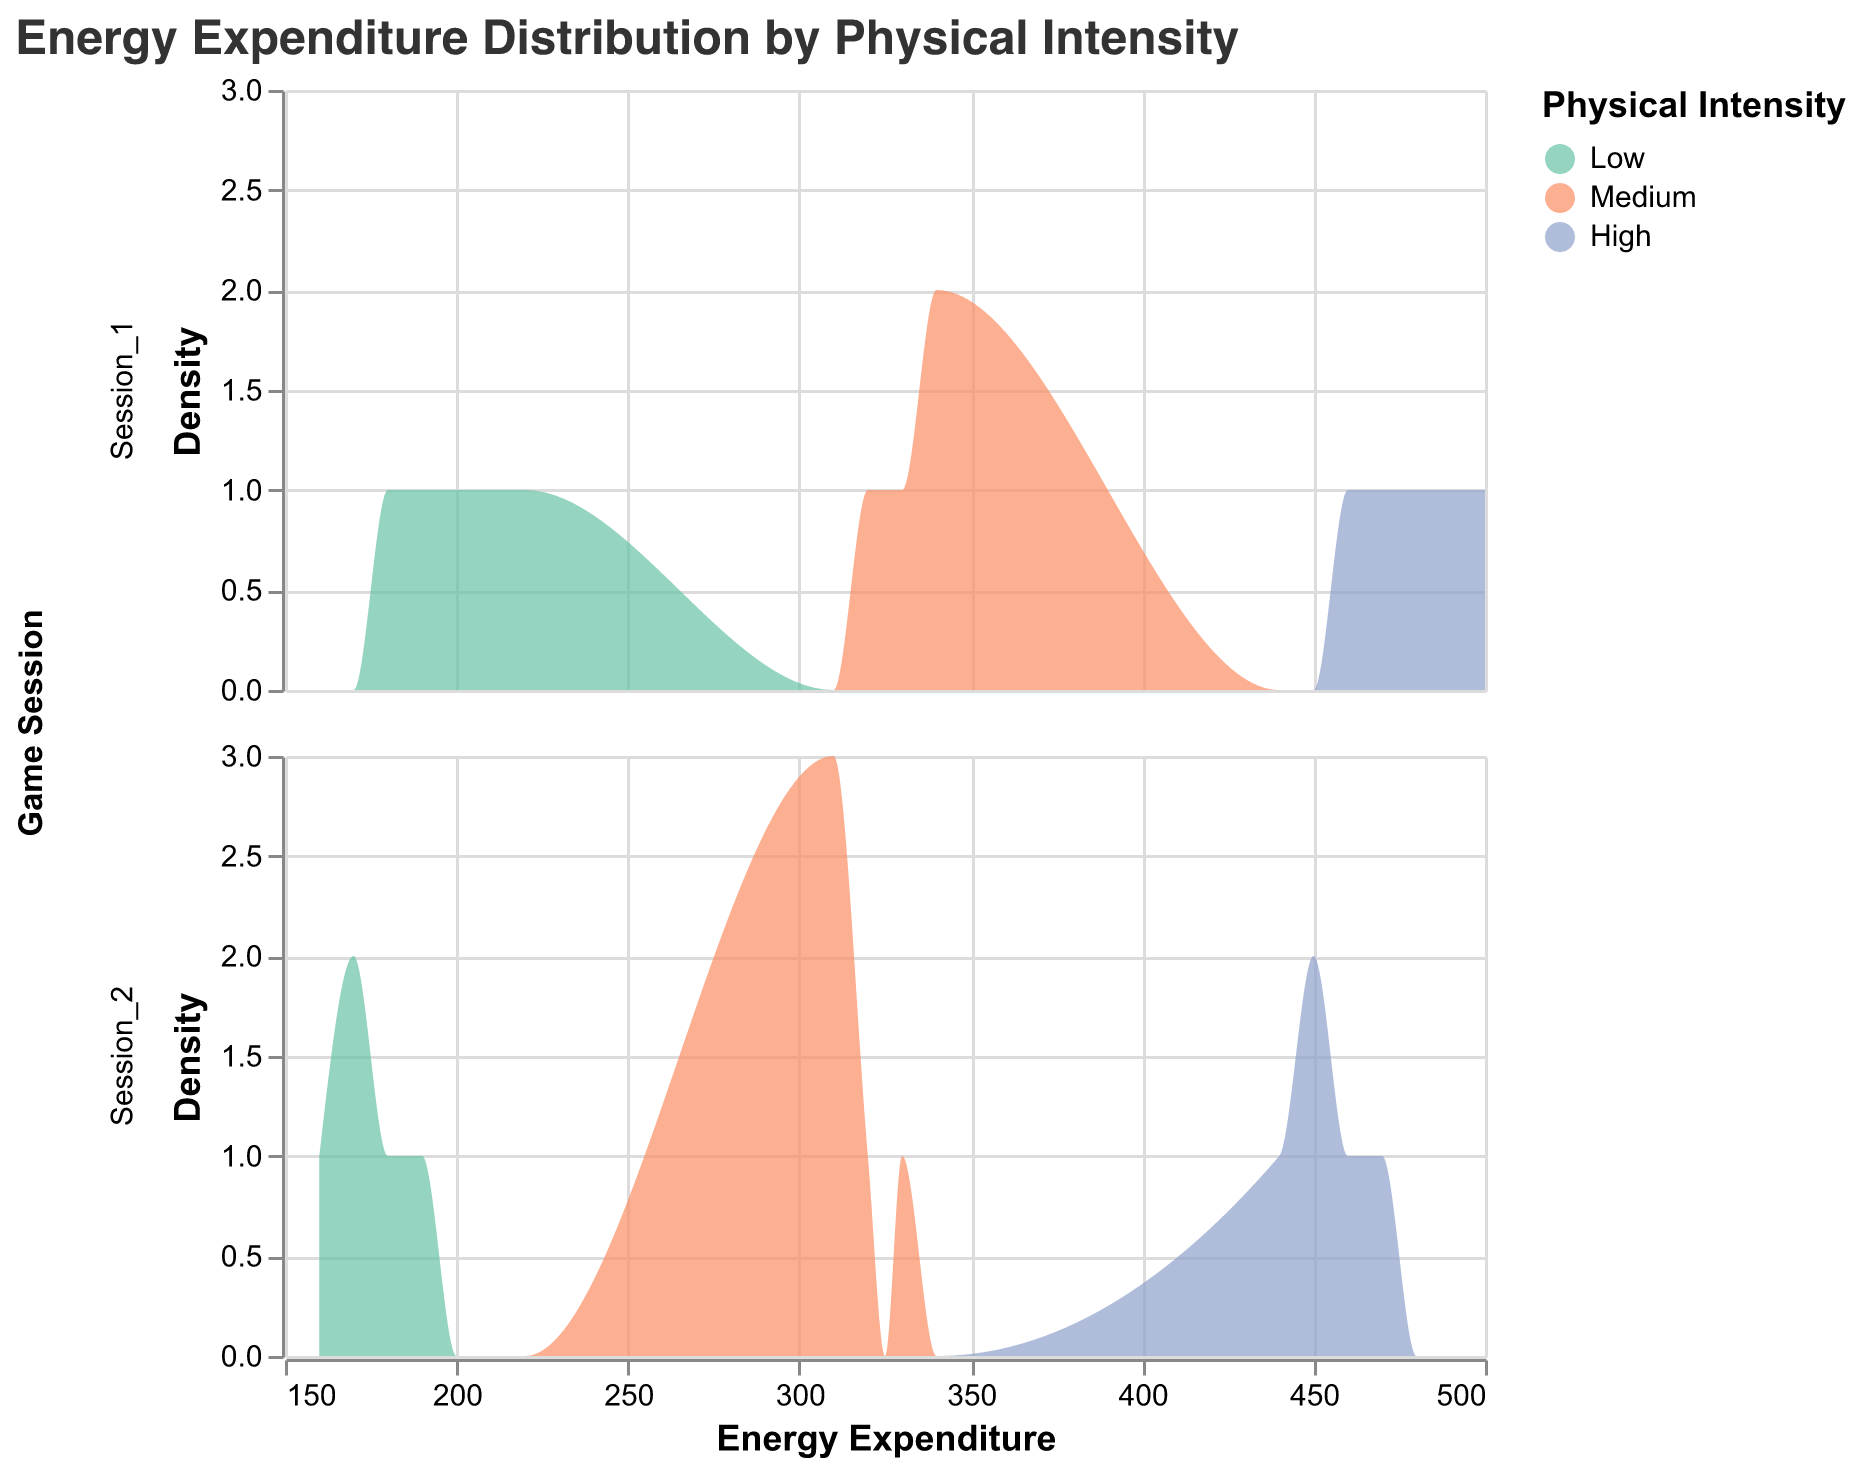What is the title of the plot? The title is located at the top of the plot and reads "Energy Expenditure Distribution by Physical Intensity".
Answer: Energy Expenditure Distribution by Physical Intensity What are the three physical intensity levels displayed in the plot? The plot uses three colors to represent physical intensity levels, identified in the legend. They are Low, Medium, and High.
Answer: Low, Medium, High Which color represents high physical intensity on the plot? The legend shows that the color representing high physical intensity is a shade of blue.
Answer: Blue Is the density distribution higher for medium intensity in Session_1 or Session_2? By comparing the height of the density distributions for medium intensity in both sessions, it is evident whether it peaks higher in Session_1 or Session_2.
Answer: Session_2 Which game session shows a wider range of energy expenditure for low physical intensity? To determine this, compare the spread of the density plot for low physical intensity across both game sessions. A wider spread indicates a wider range of energy expenditure.
Answer: Session_1 What is the most frequent energy expenditure range for high physical intensity in Session_2? By looking at the highest point (peak) of the density plot for high physical intensity in Session_2, you can pinpoint the range where energy expenditure is most frequent.
Answer: Around 450-470 Are there any game sessions where low physical intensity shows a notable overlap in energy expenditure with high physical intensity? Observe the density plots for overlaps between the distributions of low and high physical intensity in both game sessions. This would require scrutiny for any noticeable intersection.
Answer: No Which physical intensity level has the highest energy expenditure distribution across both sessions? Assess the peak of distributions for each physical intensity level in both sessions. The highest peak among these distributions indicates the highest energy expenditure level.
Answer: High 